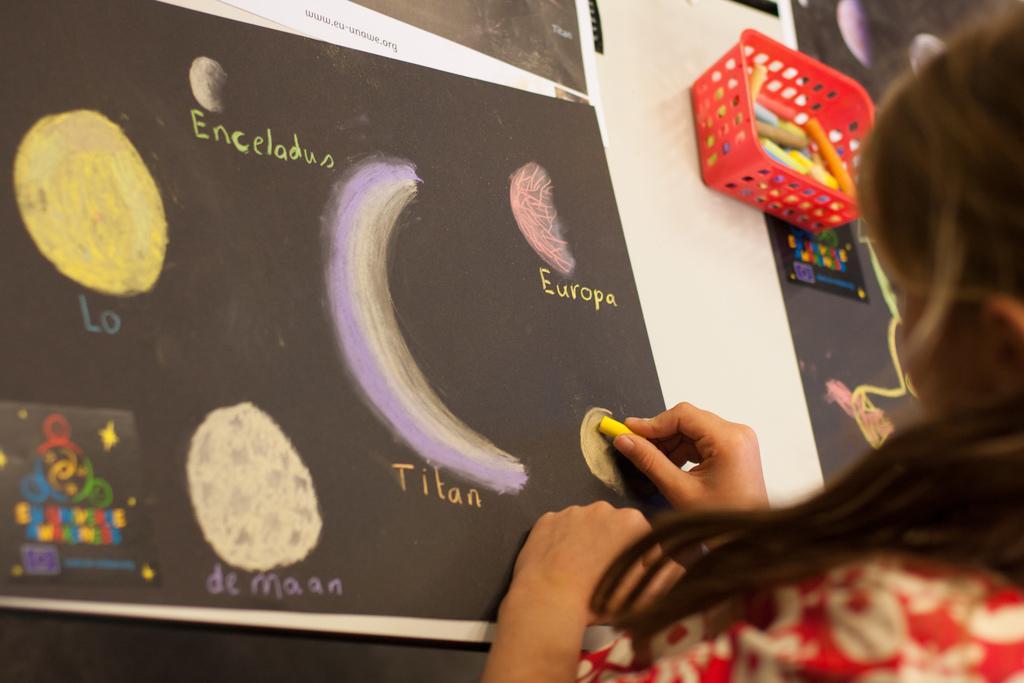Could you give a brief overview of what you see in this image? In this image we can see a chart and on the chart, we can see few diagrams and text. On the right side, we can see a person holding an object. On the top right, we can see few objects. At the top we can see some text. 